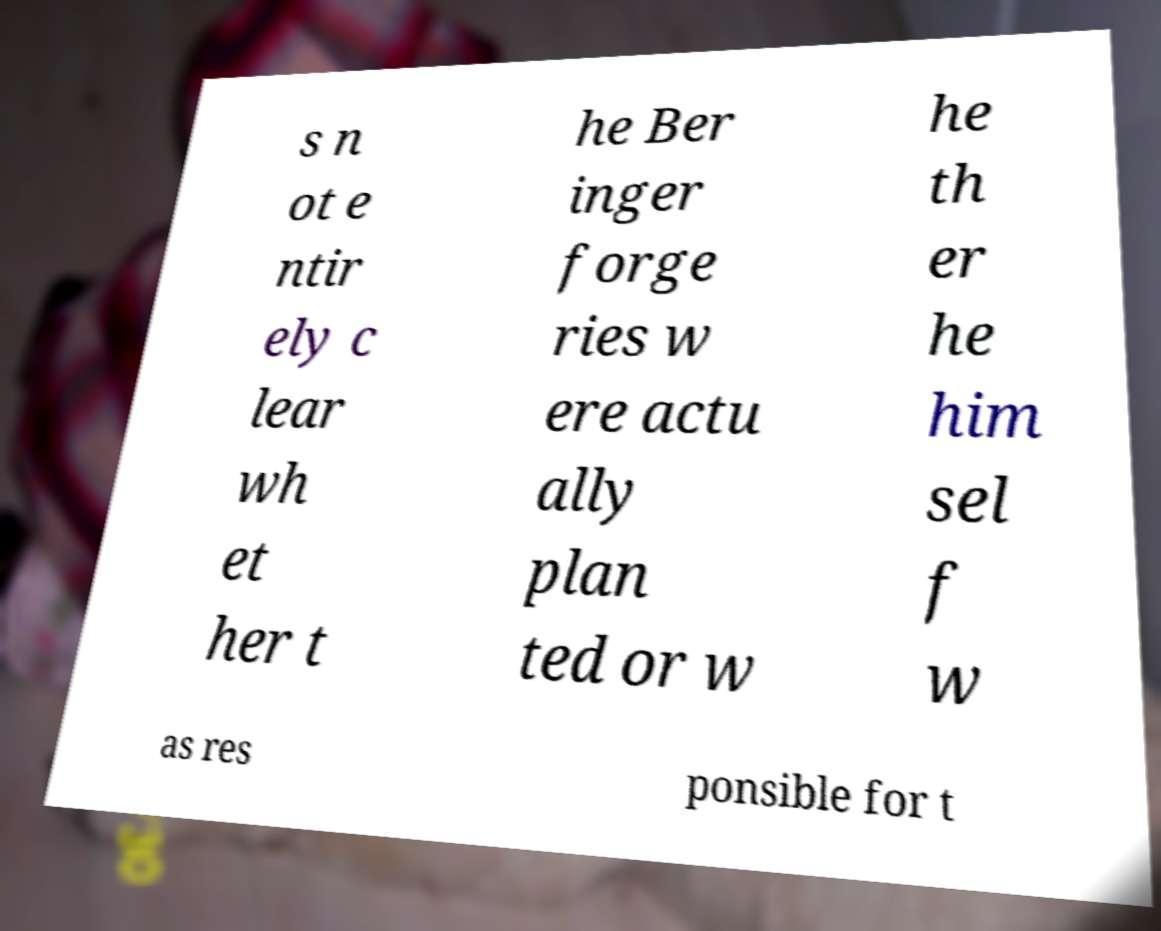What messages or text are displayed in this image? I need them in a readable, typed format. s n ot e ntir ely c lear wh et her t he Ber inger forge ries w ere actu ally plan ted or w he th er he him sel f w as res ponsible for t 